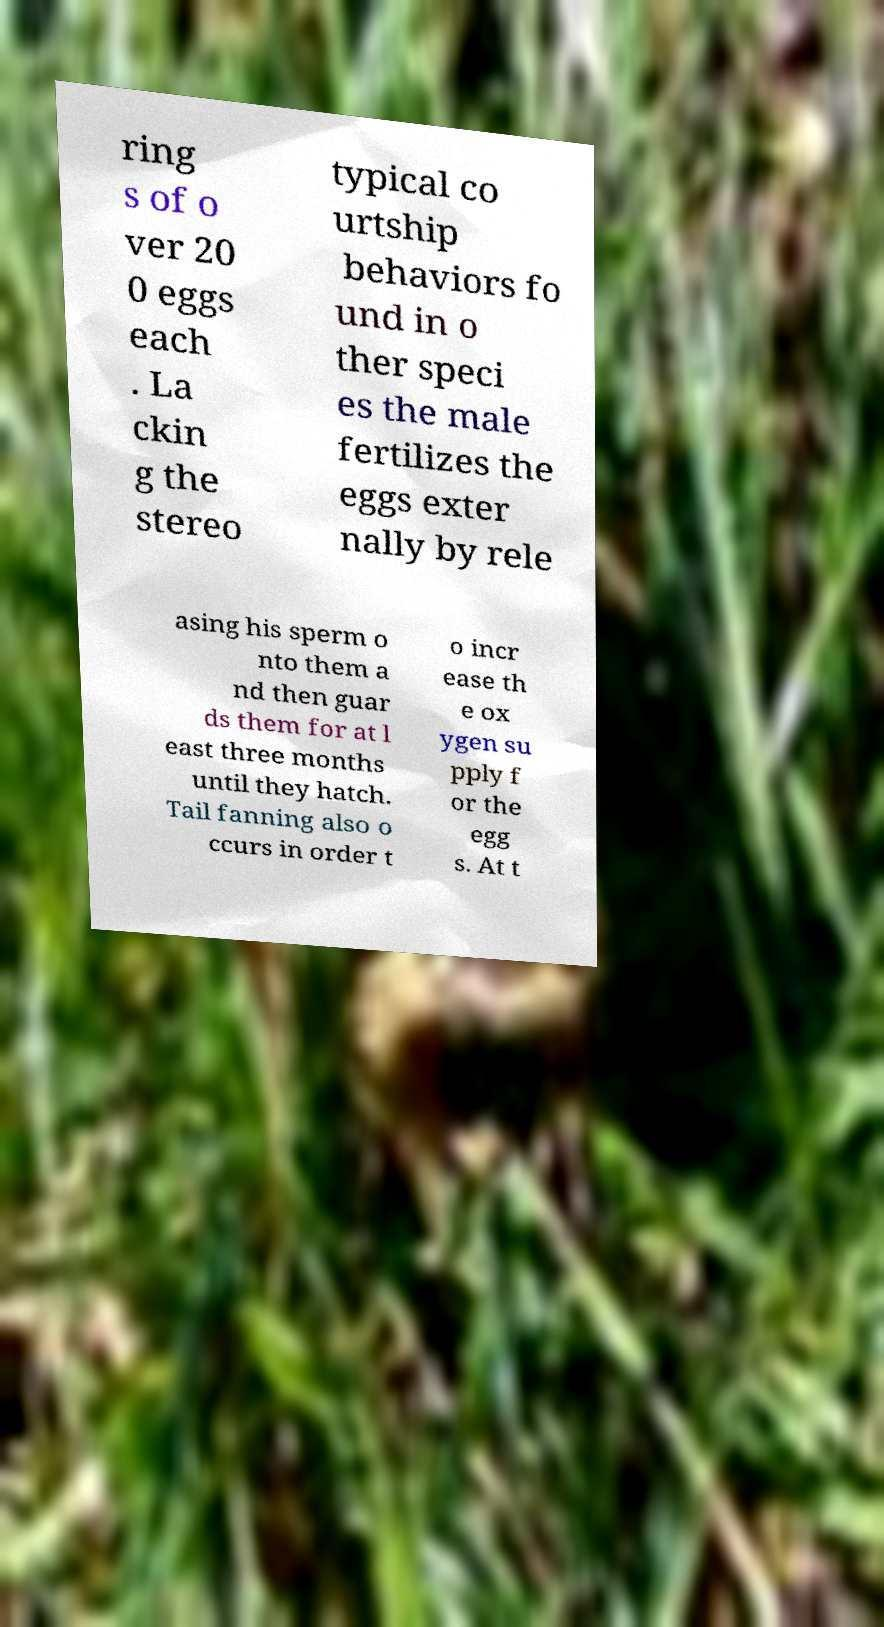Could you extract and type out the text from this image? ring s of o ver 20 0 eggs each . La ckin g the stereo typical co urtship behaviors fo und in o ther speci es the male fertilizes the eggs exter nally by rele asing his sperm o nto them a nd then guar ds them for at l east three months until they hatch. Tail fanning also o ccurs in order t o incr ease th e ox ygen su pply f or the egg s. At t 